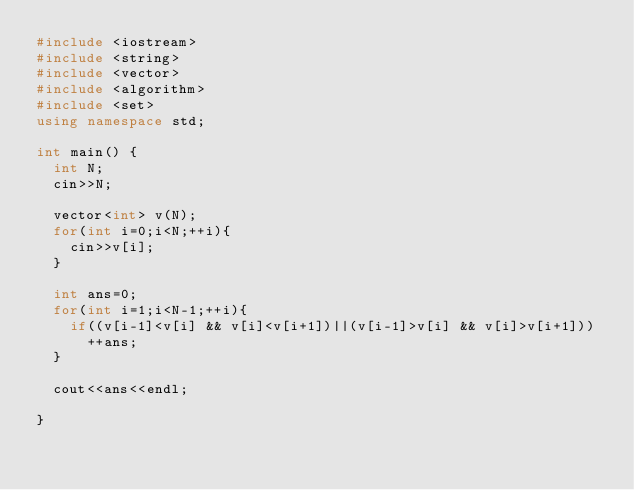Convert code to text. <code><loc_0><loc_0><loc_500><loc_500><_C++_>#include <iostream>
#include <string>
#include <vector>
#include <algorithm>
#include <set>
using namespace std;

int main() {
  int N;
  cin>>N;
  
  vector<int> v(N);
  for(int i=0;i<N;++i){
    cin>>v[i];
  }
  
  int ans=0;
  for(int i=1;i<N-1;++i){
    if((v[i-1]<v[i] && v[i]<v[i+1])||(v[i-1]>v[i] && v[i]>v[i+1]))
      ++ans;
  }
  
  cout<<ans<<endl;
  
}</code> 